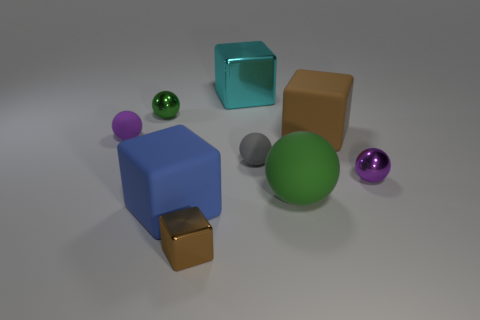Subtract 1 blocks. How many blocks are left? 3 Subtract all large balls. How many balls are left? 4 Subtract all gray spheres. How many spheres are left? 4 Subtract all red balls. Subtract all cyan cylinders. How many balls are left? 5 Add 1 large rubber blocks. How many objects exist? 10 Subtract all spheres. How many objects are left? 4 Subtract all tiny brown rubber blocks. Subtract all cyan metallic cubes. How many objects are left? 8 Add 7 tiny metal balls. How many tiny metal balls are left? 9 Add 5 large brown rubber things. How many large brown rubber things exist? 6 Subtract 0 brown cylinders. How many objects are left? 9 